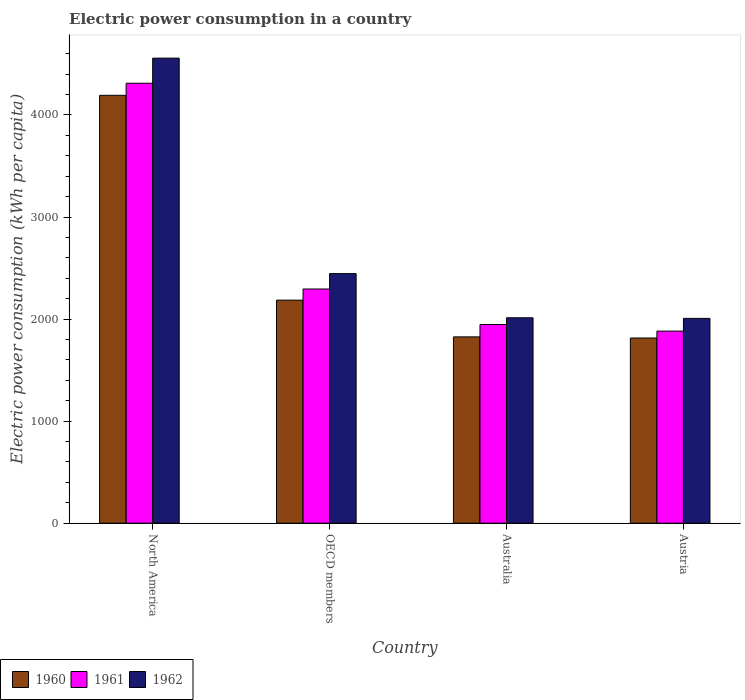How many different coloured bars are there?
Offer a very short reply. 3. How many groups of bars are there?
Your answer should be compact. 4. What is the label of the 2nd group of bars from the left?
Ensure brevity in your answer.  OECD members. What is the electric power consumption in in 1962 in Australia?
Provide a succinct answer. 2012.66. Across all countries, what is the maximum electric power consumption in in 1962?
Provide a short and direct response. 4556.78. Across all countries, what is the minimum electric power consumption in in 1961?
Ensure brevity in your answer.  1882.22. What is the total electric power consumption in in 1962 in the graph?
Your answer should be compact. 1.10e+04. What is the difference between the electric power consumption in in 1960 in Australia and that in Austria?
Your response must be concise. 10.95. What is the difference between the electric power consumption in in 1961 in Austria and the electric power consumption in in 1960 in Australia?
Make the answer very short. 56.6. What is the average electric power consumption in in 1960 per country?
Your answer should be very brief. 2504.55. What is the difference between the electric power consumption in of/in 1961 and electric power consumption in of/in 1962 in OECD members?
Provide a succinct answer. -150.79. What is the ratio of the electric power consumption in in 1962 in Australia to that in Austria?
Your answer should be very brief. 1. Is the electric power consumption in in 1961 in Australia less than that in OECD members?
Your response must be concise. Yes. Is the difference between the electric power consumption in in 1961 in Australia and OECD members greater than the difference between the electric power consumption in in 1962 in Australia and OECD members?
Offer a terse response. Yes. What is the difference between the highest and the second highest electric power consumption in in 1962?
Offer a very short reply. -2544.12. What is the difference between the highest and the lowest electric power consumption in in 1962?
Offer a very short reply. 2550.01. In how many countries, is the electric power consumption in in 1960 greater than the average electric power consumption in in 1960 taken over all countries?
Ensure brevity in your answer.  1. Is the sum of the electric power consumption in in 1961 in North America and OECD members greater than the maximum electric power consumption in in 1960 across all countries?
Give a very brief answer. Yes. What does the 1st bar from the left in North America represents?
Your answer should be compact. 1960. Is it the case that in every country, the sum of the electric power consumption in in 1960 and electric power consumption in in 1961 is greater than the electric power consumption in in 1962?
Provide a short and direct response. Yes. What is the difference between two consecutive major ticks on the Y-axis?
Offer a terse response. 1000. How many legend labels are there?
Ensure brevity in your answer.  3. How are the legend labels stacked?
Ensure brevity in your answer.  Horizontal. What is the title of the graph?
Your response must be concise. Electric power consumption in a country. What is the label or title of the Y-axis?
Make the answer very short. Electric power consumption (kWh per capita). What is the Electric power consumption (kWh per capita) of 1960 in North America?
Your answer should be compact. 4192.36. What is the Electric power consumption (kWh per capita) of 1961 in North America?
Provide a succinct answer. 4310.91. What is the Electric power consumption (kWh per capita) of 1962 in North America?
Give a very brief answer. 4556.78. What is the Electric power consumption (kWh per capita) of 1960 in OECD members?
Provide a short and direct response. 2185.53. What is the Electric power consumption (kWh per capita) of 1961 in OECD members?
Offer a very short reply. 2294.73. What is the Electric power consumption (kWh per capita) in 1962 in OECD members?
Offer a terse response. 2445.52. What is the Electric power consumption (kWh per capita) of 1960 in Australia?
Offer a very short reply. 1825.63. What is the Electric power consumption (kWh per capita) in 1961 in Australia?
Provide a succinct answer. 1947.15. What is the Electric power consumption (kWh per capita) of 1962 in Australia?
Give a very brief answer. 2012.66. What is the Electric power consumption (kWh per capita) of 1960 in Austria?
Make the answer very short. 1814.68. What is the Electric power consumption (kWh per capita) in 1961 in Austria?
Keep it short and to the point. 1882.22. What is the Electric power consumption (kWh per capita) in 1962 in Austria?
Your answer should be compact. 2006.77. Across all countries, what is the maximum Electric power consumption (kWh per capita) of 1960?
Provide a succinct answer. 4192.36. Across all countries, what is the maximum Electric power consumption (kWh per capita) of 1961?
Provide a short and direct response. 4310.91. Across all countries, what is the maximum Electric power consumption (kWh per capita) in 1962?
Give a very brief answer. 4556.78. Across all countries, what is the minimum Electric power consumption (kWh per capita) of 1960?
Ensure brevity in your answer.  1814.68. Across all countries, what is the minimum Electric power consumption (kWh per capita) of 1961?
Provide a succinct answer. 1882.22. Across all countries, what is the minimum Electric power consumption (kWh per capita) of 1962?
Provide a short and direct response. 2006.77. What is the total Electric power consumption (kWh per capita) in 1960 in the graph?
Your response must be concise. 1.00e+04. What is the total Electric power consumption (kWh per capita) of 1961 in the graph?
Give a very brief answer. 1.04e+04. What is the total Electric power consumption (kWh per capita) of 1962 in the graph?
Provide a succinct answer. 1.10e+04. What is the difference between the Electric power consumption (kWh per capita) of 1960 in North America and that in OECD members?
Your answer should be very brief. 2006.82. What is the difference between the Electric power consumption (kWh per capita) in 1961 in North America and that in OECD members?
Ensure brevity in your answer.  2016.17. What is the difference between the Electric power consumption (kWh per capita) in 1962 in North America and that in OECD members?
Offer a terse response. 2111.25. What is the difference between the Electric power consumption (kWh per capita) in 1960 in North America and that in Australia?
Your answer should be compact. 2366.73. What is the difference between the Electric power consumption (kWh per capita) of 1961 in North America and that in Australia?
Provide a short and direct response. 2363.75. What is the difference between the Electric power consumption (kWh per capita) of 1962 in North America and that in Australia?
Provide a short and direct response. 2544.12. What is the difference between the Electric power consumption (kWh per capita) in 1960 in North America and that in Austria?
Offer a terse response. 2377.68. What is the difference between the Electric power consumption (kWh per capita) in 1961 in North America and that in Austria?
Offer a very short reply. 2428.68. What is the difference between the Electric power consumption (kWh per capita) in 1962 in North America and that in Austria?
Your answer should be compact. 2550.01. What is the difference between the Electric power consumption (kWh per capita) of 1960 in OECD members and that in Australia?
Provide a succinct answer. 359.91. What is the difference between the Electric power consumption (kWh per capita) of 1961 in OECD members and that in Australia?
Provide a succinct answer. 347.58. What is the difference between the Electric power consumption (kWh per capita) of 1962 in OECD members and that in Australia?
Offer a very short reply. 432.86. What is the difference between the Electric power consumption (kWh per capita) of 1960 in OECD members and that in Austria?
Make the answer very short. 370.86. What is the difference between the Electric power consumption (kWh per capita) in 1961 in OECD members and that in Austria?
Keep it short and to the point. 412.51. What is the difference between the Electric power consumption (kWh per capita) in 1962 in OECD members and that in Austria?
Keep it short and to the point. 438.75. What is the difference between the Electric power consumption (kWh per capita) of 1960 in Australia and that in Austria?
Make the answer very short. 10.95. What is the difference between the Electric power consumption (kWh per capita) in 1961 in Australia and that in Austria?
Provide a short and direct response. 64.93. What is the difference between the Electric power consumption (kWh per capita) in 1962 in Australia and that in Austria?
Make the answer very short. 5.89. What is the difference between the Electric power consumption (kWh per capita) in 1960 in North America and the Electric power consumption (kWh per capita) in 1961 in OECD members?
Your answer should be compact. 1897.62. What is the difference between the Electric power consumption (kWh per capita) in 1960 in North America and the Electric power consumption (kWh per capita) in 1962 in OECD members?
Offer a terse response. 1746.83. What is the difference between the Electric power consumption (kWh per capita) in 1961 in North America and the Electric power consumption (kWh per capita) in 1962 in OECD members?
Your answer should be compact. 1865.38. What is the difference between the Electric power consumption (kWh per capita) in 1960 in North America and the Electric power consumption (kWh per capita) in 1961 in Australia?
Provide a succinct answer. 2245.2. What is the difference between the Electric power consumption (kWh per capita) in 1960 in North America and the Electric power consumption (kWh per capita) in 1962 in Australia?
Give a very brief answer. 2179.7. What is the difference between the Electric power consumption (kWh per capita) of 1961 in North America and the Electric power consumption (kWh per capita) of 1962 in Australia?
Give a very brief answer. 2298.24. What is the difference between the Electric power consumption (kWh per capita) of 1960 in North America and the Electric power consumption (kWh per capita) of 1961 in Austria?
Make the answer very short. 2310.13. What is the difference between the Electric power consumption (kWh per capita) of 1960 in North America and the Electric power consumption (kWh per capita) of 1962 in Austria?
Provide a succinct answer. 2185.59. What is the difference between the Electric power consumption (kWh per capita) of 1961 in North America and the Electric power consumption (kWh per capita) of 1962 in Austria?
Provide a short and direct response. 2304.13. What is the difference between the Electric power consumption (kWh per capita) of 1960 in OECD members and the Electric power consumption (kWh per capita) of 1961 in Australia?
Your answer should be very brief. 238.38. What is the difference between the Electric power consumption (kWh per capita) of 1960 in OECD members and the Electric power consumption (kWh per capita) of 1962 in Australia?
Ensure brevity in your answer.  172.87. What is the difference between the Electric power consumption (kWh per capita) of 1961 in OECD members and the Electric power consumption (kWh per capita) of 1962 in Australia?
Make the answer very short. 282.07. What is the difference between the Electric power consumption (kWh per capita) in 1960 in OECD members and the Electric power consumption (kWh per capita) in 1961 in Austria?
Make the answer very short. 303.31. What is the difference between the Electric power consumption (kWh per capita) in 1960 in OECD members and the Electric power consumption (kWh per capita) in 1962 in Austria?
Your answer should be compact. 178.76. What is the difference between the Electric power consumption (kWh per capita) in 1961 in OECD members and the Electric power consumption (kWh per capita) in 1962 in Austria?
Provide a short and direct response. 287.96. What is the difference between the Electric power consumption (kWh per capita) of 1960 in Australia and the Electric power consumption (kWh per capita) of 1961 in Austria?
Your response must be concise. -56.6. What is the difference between the Electric power consumption (kWh per capita) in 1960 in Australia and the Electric power consumption (kWh per capita) in 1962 in Austria?
Offer a terse response. -181.14. What is the difference between the Electric power consumption (kWh per capita) in 1961 in Australia and the Electric power consumption (kWh per capita) in 1962 in Austria?
Your answer should be very brief. -59.62. What is the average Electric power consumption (kWh per capita) in 1960 per country?
Your answer should be very brief. 2504.55. What is the average Electric power consumption (kWh per capita) in 1961 per country?
Give a very brief answer. 2608.75. What is the average Electric power consumption (kWh per capita) in 1962 per country?
Offer a terse response. 2755.43. What is the difference between the Electric power consumption (kWh per capita) in 1960 and Electric power consumption (kWh per capita) in 1961 in North America?
Give a very brief answer. -118.55. What is the difference between the Electric power consumption (kWh per capita) of 1960 and Electric power consumption (kWh per capita) of 1962 in North America?
Make the answer very short. -364.42. What is the difference between the Electric power consumption (kWh per capita) of 1961 and Electric power consumption (kWh per capita) of 1962 in North America?
Give a very brief answer. -245.87. What is the difference between the Electric power consumption (kWh per capita) of 1960 and Electric power consumption (kWh per capita) of 1961 in OECD members?
Provide a short and direct response. -109.2. What is the difference between the Electric power consumption (kWh per capita) in 1960 and Electric power consumption (kWh per capita) in 1962 in OECD members?
Give a very brief answer. -259.99. What is the difference between the Electric power consumption (kWh per capita) of 1961 and Electric power consumption (kWh per capita) of 1962 in OECD members?
Provide a short and direct response. -150.79. What is the difference between the Electric power consumption (kWh per capita) of 1960 and Electric power consumption (kWh per capita) of 1961 in Australia?
Give a very brief answer. -121.53. What is the difference between the Electric power consumption (kWh per capita) in 1960 and Electric power consumption (kWh per capita) in 1962 in Australia?
Provide a short and direct response. -187.03. What is the difference between the Electric power consumption (kWh per capita) in 1961 and Electric power consumption (kWh per capita) in 1962 in Australia?
Offer a terse response. -65.51. What is the difference between the Electric power consumption (kWh per capita) in 1960 and Electric power consumption (kWh per capita) in 1961 in Austria?
Offer a terse response. -67.55. What is the difference between the Electric power consumption (kWh per capita) of 1960 and Electric power consumption (kWh per capita) of 1962 in Austria?
Your answer should be very brief. -192.09. What is the difference between the Electric power consumption (kWh per capita) in 1961 and Electric power consumption (kWh per capita) in 1962 in Austria?
Keep it short and to the point. -124.55. What is the ratio of the Electric power consumption (kWh per capita) in 1960 in North America to that in OECD members?
Your answer should be compact. 1.92. What is the ratio of the Electric power consumption (kWh per capita) in 1961 in North America to that in OECD members?
Your answer should be compact. 1.88. What is the ratio of the Electric power consumption (kWh per capita) in 1962 in North America to that in OECD members?
Give a very brief answer. 1.86. What is the ratio of the Electric power consumption (kWh per capita) of 1960 in North America to that in Australia?
Make the answer very short. 2.3. What is the ratio of the Electric power consumption (kWh per capita) of 1961 in North America to that in Australia?
Make the answer very short. 2.21. What is the ratio of the Electric power consumption (kWh per capita) in 1962 in North America to that in Australia?
Your answer should be compact. 2.26. What is the ratio of the Electric power consumption (kWh per capita) in 1960 in North America to that in Austria?
Provide a succinct answer. 2.31. What is the ratio of the Electric power consumption (kWh per capita) of 1961 in North America to that in Austria?
Offer a very short reply. 2.29. What is the ratio of the Electric power consumption (kWh per capita) in 1962 in North America to that in Austria?
Ensure brevity in your answer.  2.27. What is the ratio of the Electric power consumption (kWh per capita) of 1960 in OECD members to that in Australia?
Give a very brief answer. 1.2. What is the ratio of the Electric power consumption (kWh per capita) in 1961 in OECD members to that in Australia?
Offer a very short reply. 1.18. What is the ratio of the Electric power consumption (kWh per capita) of 1962 in OECD members to that in Australia?
Make the answer very short. 1.22. What is the ratio of the Electric power consumption (kWh per capita) in 1960 in OECD members to that in Austria?
Your answer should be very brief. 1.2. What is the ratio of the Electric power consumption (kWh per capita) of 1961 in OECD members to that in Austria?
Give a very brief answer. 1.22. What is the ratio of the Electric power consumption (kWh per capita) in 1962 in OECD members to that in Austria?
Your answer should be compact. 1.22. What is the ratio of the Electric power consumption (kWh per capita) in 1960 in Australia to that in Austria?
Keep it short and to the point. 1.01. What is the ratio of the Electric power consumption (kWh per capita) of 1961 in Australia to that in Austria?
Offer a very short reply. 1.03. What is the ratio of the Electric power consumption (kWh per capita) of 1962 in Australia to that in Austria?
Your answer should be very brief. 1. What is the difference between the highest and the second highest Electric power consumption (kWh per capita) in 1960?
Provide a succinct answer. 2006.82. What is the difference between the highest and the second highest Electric power consumption (kWh per capita) of 1961?
Your answer should be compact. 2016.17. What is the difference between the highest and the second highest Electric power consumption (kWh per capita) in 1962?
Your answer should be very brief. 2111.25. What is the difference between the highest and the lowest Electric power consumption (kWh per capita) of 1960?
Offer a very short reply. 2377.68. What is the difference between the highest and the lowest Electric power consumption (kWh per capita) of 1961?
Keep it short and to the point. 2428.68. What is the difference between the highest and the lowest Electric power consumption (kWh per capita) of 1962?
Give a very brief answer. 2550.01. 